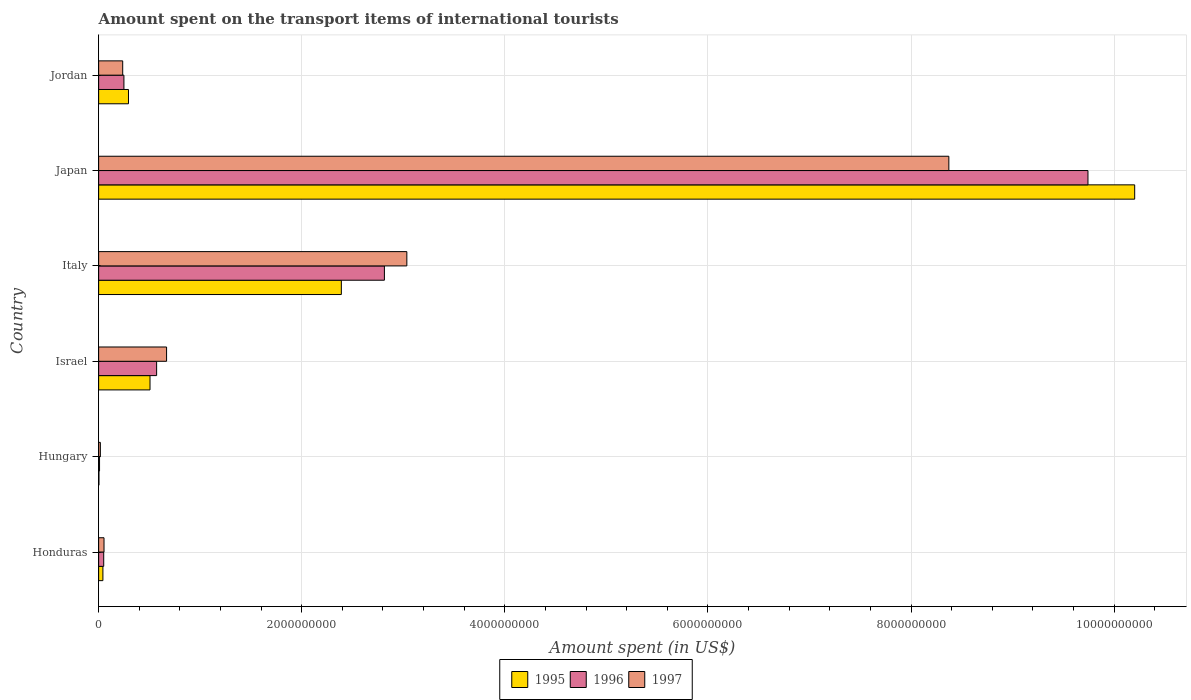How many groups of bars are there?
Your answer should be very brief. 6. What is the label of the 5th group of bars from the top?
Give a very brief answer. Hungary. In how many cases, is the number of bars for a given country not equal to the number of legend labels?
Keep it short and to the point. 0. What is the amount spent on the transport items of international tourists in 1997 in Japan?
Ensure brevity in your answer.  8.37e+09. Across all countries, what is the maximum amount spent on the transport items of international tourists in 1997?
Give a very brief answer. 8.37e+09. In which country was the amount spent on the transport items of international tourists in 1997 minimum?
Your response must be concise. Hungary. What is the total amount spent on the transport items of international tourists in 1995 in the graph?
Give a very brief answer. 1.34e+1. What is the difference between the amount spent on the transport items of international tourists in 1997 in Israel and that in Japan?
Provide a short and direct response. -7.70e+09. What is the difference between the amount spent on the transport items of international tourists in 1997 in Italy and the amount spent on the transport items of international tourists in 1996 in Hungary?
Your response must be concise. 3.03e+09. What is the average amount spent on the transport items of international tourists in 1996 per country?
Ensure brevity in your answer.  2.24e+09. What is the difference between the amount spent on the transport items of international tourists in 1995 and amount spent on the transport items of international tourists in 1997 in Honduras?
Keep it short and to the point. -1.10e+07. What is the ratio of the amount spent on the transport items of international tourists in 1996 in Honduras to that in Israel?
Provide a succinct answer. 0.09. Is the amount spent on the transport items of international tourists in 1997 in Honduras less than that in Israel?
Your response must be concise. Yes. Is the difference between the amount spent on the transport items of international tourists in 1995 in Hungary and Israel greater than the difference between the amount spent on the transport items of international tourists in 1997 in Hungary and Israel?
Offer a terse response. Yes. What is the difference between the highest and the second highest amount spent on the transport items of international tourists in 1996?
Provide a short and direct response. 6.93e+09. What is the difference between the highest and the lowest amount spent on the transport items of international tourists in 1996?
Offer a terse response. 9.73e+09. In how many countries, is the amount spent on the transport items of international tourists in 1996 greater than the average amount spent on the transport items of international tourists in 1996 taken over all countries?
Your answer should be compact. 2. Is the sum of the amount spent on the transport items of international tourists in 1996 in Honduras and Italy greater than the maximum amount spent on the transport items of international tourists in 1995 across all countries?
Provide a succinct answer. No. What does the 1st bar from the top in Jordan represents?
Provide a short and direct response. 1997. Does the graph contain any zero values?
Give a very brief answer. No. Does the graph contain grids?
Offer a terse response. Yes. Where does the legend appear in the graph?
Your answer should be very brief. Bottom center. How many legend labels are there?
Make the answer very short. 3. How are the legend labels stacked?
Your answer should be very brief. Horizontal. What is the title of the graph?
Give a very brief answer. Amount spent on the transport items of international tourists. What is the label or title of the X-axis?
Offer a terse response. Amount spent (in US$). What is the label or title of the Y-axis?
Give a very brief answer. Country. What is the Amount spent (in US$) in 1995 in Honduras?
Offer a terse response. 4.20e+07. What is the Amount spent (in US$) of 1997 in Honduras?
Ensure brevity in your answer.  5.30e+07. What is the Amount spent (in US$) of 1995 in Hungary?
Offer a terse response. 3.00e+06. What is the Amount spent (in US$) of 1996 in Hungary?
Your answer should be compact. 9.00e+06. What is the Amount spent (in US$) of 1997 in Hungary?
Provide a short and direct response. 1.70e+07. What is the Amount spent (in US$) in 1995 in Israel?
Keep it short and to the point. 5.06e+08. What is the Amount spent (in US$) in 1996 in Israel?
Ensure brevity in your answer.  5.71e+08. What is the Amount spent (in US$) of 1997 in Israel?
Make the answer very short. 6.69e+08. What is the Amount spent (in US$) in 1995 in Italy?
Provide a short and direct response. 2.39e+09. What is the Amount spent (in US$) of 1996 in Italy?
Your answer should be compact. 2.81e+09. What is the Amount spent (in US$) of 1997 in Italy?
Give a very brief answer. 3.04e+09. What is the Amount spent (in US$) in 1995 in Japan?
Ensure brevity in your answer.  1.02e+1. What is the Amount spent (in US$) of 1996 in Japan?
Your answer should be compact. 9.74e+09. What is the Amount spent (in US$) in 1997 in Japan?
Provide a succinct answer. 8.37e+09. What is the Amount spent (in US$) in 1995 in Jordan?
Provide a short and direct response. 2.94e+08. What is the Amount spent (in US$) of 1996 in Jordan?
Offer a very short reply. 2.49e+08. What is the Amount spent (in US$) of 1997 in Jordan?
Your response must be concise. 2.37e+08. Across all countries, what is the maximum Amount spent (in US$) in 1995?
Your answer should be very brief. 1.02e+1. Across all countries, what is the maximum Amount spent (in US$) of 1996?
Make the answer very short. 9.74e+09. Across all countries, what is the maximum Amount spent (in US$) in 1997?
Provide a succinct answer. 8.37e+09. Across all countries, what is the minimum Amount spent (in US$) of 1995?
Your answer should be very brief. 3.00e+06. Across all countries, what is the minimum Amount spent (in US$) of 1996?
Provide a succinct answer. 9.00e+06. Across all countries, what is the minimum Amount spent (in US$) of 1997?
Make the answer very short. 1.70e+07. What is the total Amount spent (in US$) in 1995 in the graph?
Ensure brevity in your answer.  1.34e+1. What is the total Amount spent (in US$) of 1996 in the graph?
Make the answer very short. 1.34e+1. What is the total Amount spent (in US$) in 1997 in the graph?
Ensure brevity in your answer.  1.24e+1. What is the difference between the Amount spent (in US$) in 1995 in Honduras and that in Hungary?
Keep it short and to the point. 3.90e+07. What is the difference between the Amount spent (in US$) in 1996 in Honduras and that in Hungary?
Ensure brevity in your answer.  4.10e+07. What is the difference between the Amount spent (in US$) of 1997 in Honduras and that in Hungary?
Keep it short and to the point. 3.60e+07. What is the difference between the Amount spent (in US$) of 1995 in Honduras and that in Israel?
Ensure brevity in your answer.  -4.64e+08. What is the difference between the Amount spent (in US$) in 1996 in Honduras and that in Israel?
Make the answer very short. -5.21e+08. What is the difference between the Amount spent (in US$) of 1997 in Honduras and that in Israel?
Offer a terse response. -6.16e+08. What is the difference between the Amount spent (in US$) in 1995 in Honduras and that in Italy?
Your response must be concise. -2.35e+09. What is the difference between the Amount spent (in US$) in 1996 in Honduras and that in Italy?
Keep it short and to the point. -2.76e+09. What is the difference between the Amount spent (in US$) in 1997 in Honduras and that in Italy?
Your response must be concise. -2.98e+09. What is the difference between the Amount spent (in US$) in 1995 in Honduras and that in Japan?
Offer a very short reply. -1.02e+1. What is the difference between the Amount spent (in US$) of 1996 in Honduras and that in Japan?
Offer a terse response. -9.69e+09. What is the difference between the Amount spent (in US$) of 1997 in Honduras and that in Japan?
Offer a very short reply. -8.32e+09. What is the difference between the Amount spent (in US$) in 1995 in Honduras and that in Jordan?
Make the answer very short. -2.52e+08. What is the difference between the Amount spent (in US$) in 1996 in Honduras and that in Jordan?
Give a very brief answer. -1.99e+08. What is the difference between the Amount spent (in US$) in 1997 in Honduras and that in Jordan?
Your response must be concise. -1.84e+08. What is the difference between the Amount spent (in US$) in 1995 in Hungary and that in Israel?
Make the answer very short. -5.03e+08. What is the difference between the Amount spent (in US$) in 1996 in Hungary and that in Israel?
Offer a very short reply. -5.62e+08. What is the difference between the Amount spent (in US$) of 1997 in Hungary and that in Israel?
Keep it short and to the point. -6.52e+08. What is the difference between the Amount spent (in US$) in 1995 in Hungary and that in Italy?
Offer a very short reply. -2.39e+09. What is the difference between the Amount spent (in US$) of 1996 in Hungary and that in Italy?
Keep it short and to the point. -2.80e+09. What is the difference between the Amount spent (in US$) of 1997 in Hungary and that in Italy?
Keep it short and to the point. -3.02e+09. What is the difference between the Amount spent (in US$) of 1995 in Hungary and that in Japan?
Give a very brief answer. -1.02e+1. What is the difference between the Amount spent (in US$) of 1996 in Hungary and that in Japan?
Offer a very short reply. -9.73e+09. What is the difference between the Amount spent (in US$) of 1997 in Hungary and that in Japan?
Ensure brevity in your answer.  -8.36e+09. What is the difference between the Amount spent (in US$) of 1995 in Hungary and that in Jordan?
Your answer should be very brief. -2.91e+08. What is the difference between the Amount spent (in US$) of 1996 in Hungary and that in Jordan?
Your response must be concise. -2.40e+08. What is the difference between the Amount spent (in US$) of 1997 in Hungary and that in Jordan?
Your answer should be compact. -2.20e+08. What is the difference between the Amount spent (in US$) in 1995 in Israel and that in Italy?
Your answer should be compact. -1.88e+09. What is the difference between the Amount spent (in US$) of 1996 in Israel and that in Italy?
Make the answer very short. -2.24e+09. What is the difference between the Amount spent (in US$) in 1997 in Israel and that in Italy?
Your response must be concise. -2.37e+09. What is the difference between the Amount spent (in US$) in 1995 in Israel and that in Japan?
Your response must be concise. -9.70e+09. What is the difference between the Amount spent (in US$) of 1996 in Israel and that in Japan?
Your response must be concise. -9.17e+09. What is the difference between the Amount spent (in US$) in 1997 in Israel and that in Japan?
Offer a very short reply. -7.70e+09. What is the difference between the Amount spent (in US$) in 1995 in Israel and that in Jordan?
Keep it short and to the point. 2.12e+08. What is the difference between the Amount spent (in US$) of 1996 in Israel and that in Jordan?
Give a very brief answer. 3.22e+08. What is the difference between the Amount spent (in US$) in 1997 in Israel and that in Jordan?
Your response must be concise. 4.32e+08. What is the difference between the Amount spent (in US$) of 1995 in Italy and that in Japan?
Make the answer very short. -7.81e+09. What is the difference between the Amount spent (in US$) of 1996 in Italy and that in Japan?
Give a very brief answer. -6.93e+09. What is the difference between the Amount spent (in US$) of 1997 in Italy and that in Japan?
Give a very brief answer. -5.34e+09. What is the difference between the Amount spent (in US$) in 1995 in Italy and that in Jordan?
Your answer should be compact. 2.10e+09. What is the difference between the Amount spent (in US$) of 1996 in Italy and that in Jordan?
Give a very brief answer. 2.56e+09. What is the difference between the Amount spent (in US$) of 1997 in Italy and that in Jordan?
Provide a short and direct response. 2.80e+09. What is the difference between the Amount spent (in US$) of 1995 in Japan and that in Jordan?
Offer a terse response. 9.91e+09. What is the difference between the Amount spent (in US$) in 1996 in Japan and that in Jordan?
Keep it short and to the point. 9.49e+09. What is the difference between the Amount spent (in US$) of 1997 in Japan and that in Jordan?
Offer a very short reply. 8.14e+09. What is the difference between the Amount spent (in US$) in 1995 in Honduras and the Amount spent (in US$) in 1996 in Hungary?
Offer a very short reply. 3.30e+07. What is the difference between the Amount spent (in US$) of 1995 in Honduras and the Amount spent (in US$) of 1997 in Hungary?
Provide a short and direct response. 2.50e+07. What is the difference between the Amount spent (in US$) of 1996 in Honduras and the Amount spent (in US$) of 1997 in Hungary?
Ensure brevity in your answer.  3.30e+07. What is the difference between the Amount spent (in US$) of 1995 in Honduras and the Amount spent (in US$) of 1996 in Israel?
Give a very brief answer. -5.29e+08. What is the difference between the Amount spent (in US$) of 1995 in Honduras and the Amount spent (in US$) of 1997 in Israel?
Offer a very short reply. -6.27e+08. What is the difference between the Amount spent (in US$) in 1996 in Honduras and the Amount spent (in US$) in 1997 in Israel?
Provide a short and direct response. -6.19e+08. What is the difference between the Amount spent (in US$) in 1995 in Honduras and the Amount spent (in US$) in 1996 in Italy?
Provide a succinct answer. -2.77e+09. What is the difference between the Amount spent (in US$) of 1995 in Honduras and the Amount spent (in US$) of 1997 in Italy?
Offer a very short reply. -2.99e+09. What is the difference between the Amount spent (in US$) of 1996 in Honduras and the Amount spent (in US$) of 1997 in Italy?
Keep it short and to the point. -2.98e+09. What is the difference between the Amount spent (in US$) in 1995 in Honduras and the Amount spent (in US$) in 1996 in Japan?
Provide a succinct answer. -9.70e+09. What is the difference between the Amount spent (in US$) of 1995 in Honduras and the Amount spent (in US$) of 1997 in Japan?
Keep it short and to the point. -8.33e+09. What is the difference between the Amount spent (in US$) in 1996 in Honduras and the Amount spent (in US$) in 1997 in Japan?
Keep it short and to the point. -8.32e+09. What is the difference between the Amount spent (in US$) in 1995 in Honduras and the Amount spent (in US$) in 1996 in Jordan?
Provide a short and direct response. -2.07e+08. What is the difference between the Amount spent (in US$) of 1995 in Honduras and the Amount spent (in US$) of 1997 in Jordan?
Your answer should be compact. -1.95e+08. What is the difference between the Amount spent (in US$) in 1996 in Honduras and the Amount spent (in US$) in 1997 in Jordan?
Your answer should be very brief. -1.87e+08. What is the difference between the Amount spent (in US$) of 1995 in Hungary and the Amount spent (in US$) of 1996 in Israel?
Provide a short and direct response. -5.68e+08. What is the difference between the Amount spent (in US$) of 1995 in Hungary and the Amount spent (in US$) of 1997 in Israel?
Your answer should be very brief. -6.66e+08. What is the difference between the Amount spent (in US$) in 1996 in Hungary and the Amount spent (in US$) in 1997 in Israel?
Ensure brevity in your answer.  -6.60e+08. What is the difference between the Amount spent (in US$) in 1995 in Hungary and the Amount spent (in US$) in 1996 in Italy?
Make the answer very short. -2.81e+09. What is the difference between the Amount spent (in US$) in 1995 in Hungary and the Amount spent (in US$) in 1997 in Italy?
Your answer should be compact. -3.03e+09. What is the difference between the Amount spent (in US$) in 1996 in Hungary and the Amount spent (in US$) in 1997 in Italy?
Provide a short and direct response. -3.03e+09. What is the difference between the Amount spent (in US$) of 1995 in Hungary and the Amount spent (in US$) of 1996 in Japan?
Offer a very short reply. -9.74e+09. What is the difference between the Amount spent (in US$) of 1995 in Hungary and the Amount spent (in US$) of 1997 in Japan?
Offer a very short reply. -8.37e+09. What is the difference between the Amount spent (in US$) of 1996 in Hungary and the Amount spent (in US$) of 1997 in Japan?
Provide a short and direct response. -8.36e+09. What is the difference between the Amount spent (in US$) of 1995 in Hungary and the Amount spent (in US$) of 1996 in Jordan?
Offer a terse response. -2.46e+08. What is the difference between the Amount spent (in US$) of 1995 in Hungary and the Amount spent (in US$) of 1997 in Jordan?
Your response must be concise. -2.34e+08. What is the difference between the Amount spent (in US$) in 1996 in Hungary and the Amount spent (in US$) in 1997 in Jordan?
Your response must be concise. -2.28e+08. What is the difference between the Amount spent (in US$) of 1995 in Israel and the Amount spent (in US$) of 1996 in Italy?
Your response must be concise. -2.31e+09. What is the difference between the Amount spent (in US$) of 1995 in Israel and the Amount spent (in US$) of 1997 in Italy?
Give a very brief answer. -2.53e+09. What is the difference between the Amount spent (in US$) in 1996 in Israel and the Amount spent (in US$) in 1997 in Italy?
Make the answer very short. -2.46e+09. What is the difference between the Amount spent (in US$) of 1995 in Israel and the Amount spent (in US$) of 1996 in Japan?
Make the answer very short. -9.24e+09. What is the difference between the Amount spent (in US$) in 1995 in Israel and the Amount spent (in US$) in 1997 in Japan?
Your response must be concise. -7.87e+09. What is the difference between the Amount spent (in US$) of 1996 in Israel and the Amount spent (in US$) of 1997 in Japan?
Your answer should be very brief. -7.80e+09. What is the difference between the Amount spent (in US$) of 1995 in Israel and the Amount spent (in US$) of 1996 in Jordan?
Ensure brevity in your answer.  2.57e+08. What is the difference between the Amount spent (in US$) in 1995 in Israel and the Amount spent (in US$) in 1997 in Jordan?
Your answer should be compact. 2.69e+08. What is the difference between the Amount spent (in US$) of 1996 in Israel and the Amount spent (in US$) of 1997 in Jordan?
Offer a terse response. 3.34e+08. What is the difference between the Amount spent (in US$) of 1995 in Italy and the Amount spent (in US$) of 1996 in Japan?
Make the answer very short. -7.35e+09. What is the difference between the Amount spent (in US$) of 1995 in Italy and the Amount spent (in US$) of 1997 in Japan?
Ensure brevity in your answer.  -5.98e+09. What is the difference between the Amount spent (in US$) of 1996 in Italy and the Amount spent (in US$) of 1997 in Japan?
Ensure brevity in your answer.  -5.56e+09. What is the difference between the Amount spent (in US$) in 1995 in Italy and the Amount spent (in US$) in 1996 in Jordan?
Keep it short and to the point. 2.14e+09. What is the difference between the Amount spent (in US$) of 1995 in Italy and the Amount spent (in US$) of 1997 in Jordan?
Offer a terse response. 2.15e+09. What is the difference between the Amount spent (in US$) in 1996 in Italy and the Amount spent (in US$) in 1997 in Jordan?
Your answer should be compact. 2.58e+09. What is the difference between the Amount spent (in US$) of 1995 in Japan and the Amount spent (in US$) of 1996 in Jordan?
Keep it short and to the point. 9.95e+09. What is the difference between the Amount spent (in US$) of 1995 in Japan and the Amount spent (in US$) of 1997 in Jordan?
Ensure brevity in your answer.  9.96e+09. What is the difference between the Amount spent (in US$) in 1996 in Japan and the Amount spent (in US$) in 1997 in Jordan?
Ensure brevity in your answer.  9.50e+09. What is the average Amount spent (in US$) in 1995 per country?
Keep it short and to the point. 2.24e+09. What is the average Amount spent (in US$) in 1996 per country?
Your answer should be very brief. 2.24e+09. What is the average Amount spent (in US$) of 1997 per country?
Your response must be concise. 2.06e+09. What is the difference between the Amount spent (in US$) of 1995 and Amount spent (in US$) of 1996 in Honduras?
Make the answer very short. -8.00e+06. What is the difference between the Amount spent (in US$) in 1995 and Amount spent (in US$) in 1997 in Honduras?
Make the answer very short. -1.10e+07. What is the difference between the Amount spent (in US$) of 1996 and Amount spent (in US$) of 1997 in Honduras?
Offer a very short reply. -3.00e+06. What is the difference between the Amount spent (in US$) of 1995 and Amount spent (in US$) of 1996 in Hungary?
Your response must be concise. -6.00e+06. What is the difference between the Amount spent (in US$) of 1995 and Amount spent (in US$) of 1997 in Hungary?
Your answer should be compact. -1.40e+07. What is the difference between the Amount spent (in US$) of 1996 and Amount spent (in US$) of 1997 in Hungary?
Offer a very short reply. -8.00e+06. What is the difference between the Amount spent (in US$) of 1995 and Amount spent (in US$) of 1996 in Israel?
Your response must be concise. -6.50e+07. What is the difference between the Amount spent (in US$) of 1995 and Amount spent (in US$) of 1997 in Israel?
Your response must be concise. -1.63e+08. What is the difference between the Amount spent (in US$) in 1996 and Amount spent (in US$) in 1997 in Israel?
Offer a very short reply. -9.80e+07. What is the difference between the Amount spent (in US$) of 1995 and Amount spent (in US$) of 1996 in Italy?
Your answer should be compact. -4.24e+08. What is the difference between the Amount spent (in US$) in 1995 and Amount spent (in US$) in 1997 in Italy?
Ensure brevity in your answer.  -6.45e+08. What is the difference between the Amount spent (in US$) in 1996 and Amount spent (in US$) in 1997 in Italy?
Provide a succinct answer. -2.21e+08. What is the difference between the Amount spent (in US$) in 1995 and Amount spent (in US$) in 1996 in Japan?
Make the answer very short. 4.60e+08. What is the difference between the Amount spent (in US$) of 1995 and Amount spent (in US$) of 1997 in Japan?
Your answer should be compact. 1.83e+09. What is the difference between the Amount spent (in US$) of 1996 and Amount spent (in US$) of 1997 in Japan?
Keep it short and to the point. 1.37e+09. What is the difference between the Amount spent (in US$) in 1995 and Amount spent (in US$) in 1996 in Jordan?
Keep it short and to the point. 4.50e+07. What is the difference between the Amount spent (in US$) in 1995 and Amount spent (in US$) in 1997 in Jordan?
Your answer should be compact. 5.70e+07. What is the ratio of the Amount spent (in US$) in 1995 in Honduras to that in Hungary?
Your answer should be compact. 14. What is the ratio of the Amount spent (in US$) in 1996 in Honduras to that in Hungary?
Keep it short and to the point. 5.56. What is the ratio of the Amount spent (in US$) of 1997 in Honduras to that in Hungary?
Your response must be concise. 3.12. What is the ratio of the Amount spent (in US$) in 1995 in Honduras to that in Israel?
Your answer should be very brief. 0.08. What is the ratio of the Amount spent (in US$) of 1996 in Honduras to that in Israel?
Provide a short and direct response. 0.09. What is the ratio of the Amount spent (in US$) of 1997 in Honduras to that in Israel?
Ensure brevity in your answer.  0.08. What is the ratio of the Amount spent (in US$) in 1995 in Honduras to that in Italy?
Make the answer very short. 0.02. What is the ratio of the Amount spent (in US$) in 1996 in Honduras to that in Italy?
Provide a short and direct response. 0.02. What is the ratio of the Amount spent (in US$) of 1997 in Honduras to that in Italy?
Your answer should be compact. 0.02. What is the ratio of the Amount spent (in US$) in 1995 in Honduras to that in Japan?
Your answer should be very brief. 0. What is the ratio of the Amount spent (in US$) in 1996 in Honduras to that in Japan?
Offer a very short reply. 0.01. What is the ratio of the Amount spent (in US$) in 1997 in Honduras to that in Japan?
Offer a very short reply. 0.01. What is the ratio of the Amount spent (in US$) of 1995 in Honduras to that in Jordan?
Keep it short and to the point. 0.14. What is the ratio of the Amount spent (in US$) of 1996 in Honduras to that in Jordan?
Offer a terse response. 0.2. What is the ratio of the Amount spent (in US$) of 1997 in Honduras to that in Jordan?
Ensure brevity in your answer.  0.22. What is the ratio of the Amount spent (in US$) of 1995 in Hungary to that in Israel?
Your response must be concise. 0.01. What is the ratio of the Amount spent (in US$) of 1996 in Hungary to that in Israel?
Ensure brevity in your answer.  0.02. What is the ratio of the Amount spent (in US$) in 1997 in Hungary to that in Israel?
Offer a terse response. 0.03. What is the ratio of the Amount spent (in US$) of 1995 in Hungary to that in Italy?
Provide a short and direct response. 0. What is the ratio of the Amount spent (in US$) of 1996 in Hungary to that in Italy?
Keep it short and to the point. 0. What is the ratio of the Amount spent (in US$) in 1997 in Hungary to that in Italy?
Offer a very short reply. 0.01. What is the ratio of the Amount spent (in US$) of 1996 in Hungary to that in Japan?
Provide a short and direct response. 0. What is the ratio of the Amount spent (in US$) in 1997 in Hungary to that in Japan?
Keep it short and to the point. 0. What is the ratio of the Amount spent (in US$) in 1995 in Hungary to that in Jordan?
Offer a terse response. 0.01. What is the ratio of the Amount spent (in US$) in 1996 in Hungary to that in Jordan?
Provide a short and direct response. 0.04. What is the ratio of the Amount spent (in US$) of 1997 in Hungary to that in Jordan?
Provide a short and direct response. 0.07. What is the ratio of the Amount spent (in US$) of 1995 in Israel to that in Italy?
Your response must be concise. 0.21. What is the ratio of the Amount spent (in US$) of 1996 in Israel to that in Italy?
Keep it short and to the point. 0.2. What is the ratio of the Amount spent (in US$) of 1997 in Israel to that in Italy?
Ensure brevity in your answer.  0.22. What is the ratio of the Amount spent (in US$) in 1995 in Israel to that in Japan?
Your answer should be very brief. 0.05. What is the ratio of the Amount spent (in US$) in 1996 in Israel to that in Japan?
Give a very brief answer. 0.06. What is the ratio of the Amount spent (in US$) in 1997 in Israel to that in Japan?
Offer a very short reply. 0.08. What is the ratio of the Amount spent (in US$) in 1995 in Israel to that in Jordan?
Ensure brevity in your answer.  1.72. What is the ratio of the Amount spent (in US$) of 1996 in Israel to that in Jordan?
Offer a terse response. 2.29. What is the ratio of the Amount spent (in US$) in 1997 in Israel to that in Jordan?
Keep it short and to the point. 2.82. What is the ratio of the Amount spent (in US$) in 1995 in Italy to that in Japan?
Ensure brevity in your answer.  0.23. What is the ratio of the Amount spent (in US$) in 1996 in Italy to that in Japan?
Keep it short and to the point. 0.29. What is the ratio of the Amount spent (in US$) in 1997 in Italy to that in Japan?
Offer a terse response. 0.36. What is the ratio of the Amount spent (in US$) in 1995 in Italy to that in Jordan?
Give a very brief answer. 8.13. What is the ratio of the Amount spent (in US$) of 1996 in Italy to that in Jordan?
Provide a short and direct response. 11.3. What is the ratio of the Amount spent (in US$) of 1997 in Italy to that in Jordan?
Your answer should be compact. 12.81. What is the ratio of the Amount spent (in US$) of 1995 in Japan to that in Jordan?
Your answer should be compact. 34.7. What is the ratio of the Amount spent (in US$) in 1996 in Japan to that in Jordan?
Your answer should be very brief. 39.12. What is the ratio of the Amount spent (in US$) in 1997 in Japan to that in Jordan?
Make the answer very short. 35.32. What is the difference between the highest and the second highest Amount spent (in US$) in 1995?
Keep it short and to the point. 7.81e+09. What is the difference between the highest and the second highest Amount spent (in US$) of 1996?
Offer a very short reply. 6.93e+09. What is the difference between the highest and the second highest Amount spent (in US$) in 1997?
Ensure brevity in your answer.  5.34e+09. What is the difference between the highest and the lowest Amount spent (in US$) in 1995?
Provide a succinct answer. 1.02e+1. What is the difference between the highest and the lowest Amount spent (in US$) in 1996?
Make the answer very short. 9.73e+09. What is the difference between the highest and the lowest Amount spent (in US$) of 1997?
Provide a succinct answer. 8.36e+09. 